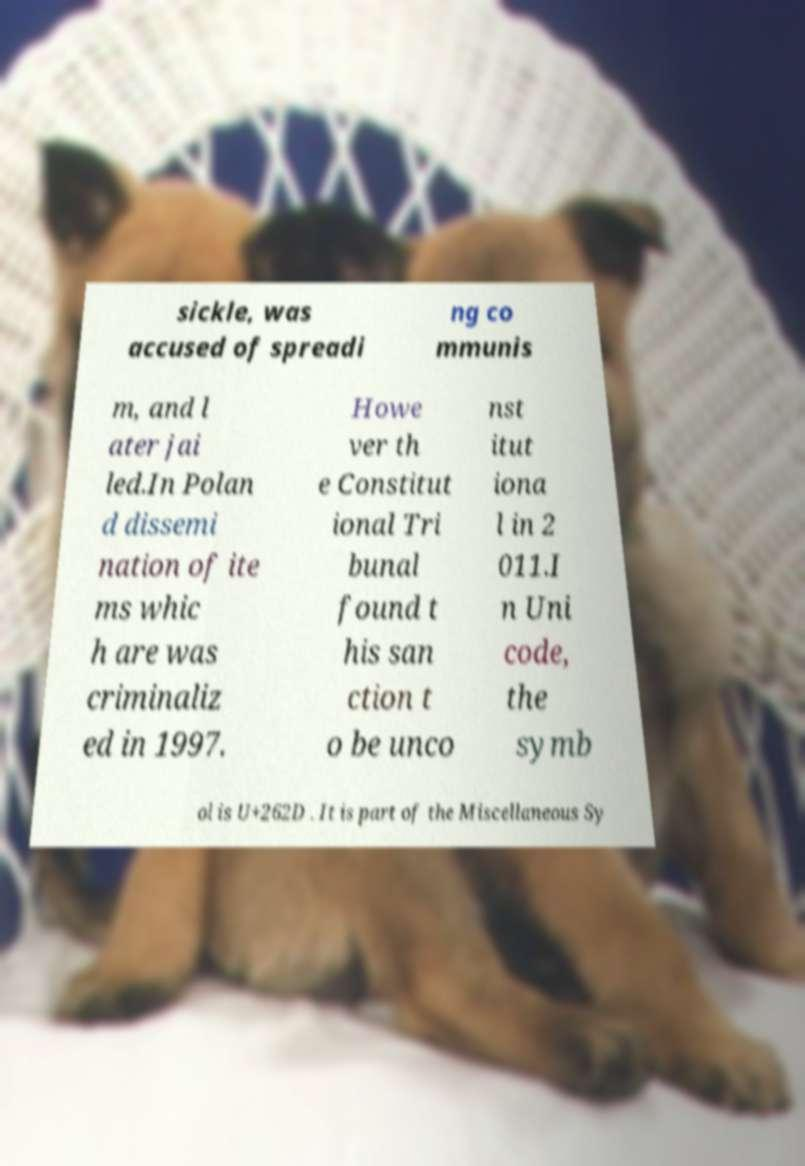I need the written content from this picture converted into text. Can you do that? sickle, was accused of spreadi ng co mmunis m, and l ater jai led.In Polan d dissemi nation of ite ms whic h are was criminaliz ed in 1997. Howe ver th e Constitut ional Tri bunal found t his san ction t o be unco nst itut iona l in 2 011.I n Uni code, the symb ol is U+262D . It is part of the Miscellaneous Sy 